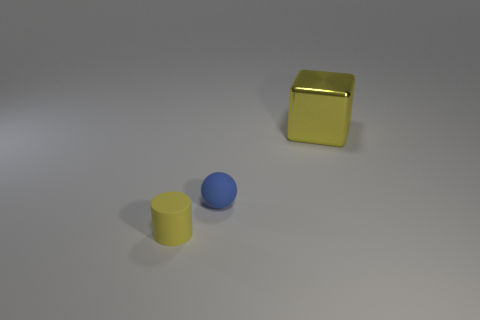Add 2 small cyan metal cylinders. How many objects exist? 5 Subtract all cylinders. How many objects are left? 2 Subtract 1 blue balls. How many objects are left? 2 Subtract all small purple metal things. Subtract all blocks. How many objects are left? 2 Add 2 large yellow metal things. How many large yellow metal things are left? 3 Add 1 yellow matte cylinders. How many yellow matte cylinders exist? 2 